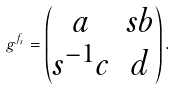<formula> <loc_0><loc_0><loc_500><loc_500>g ^ { f _ { s } } = \begin{pmatrix} a & s b \\ s ^ { - 1 } c & d \end{pmatrix} .</formula> 